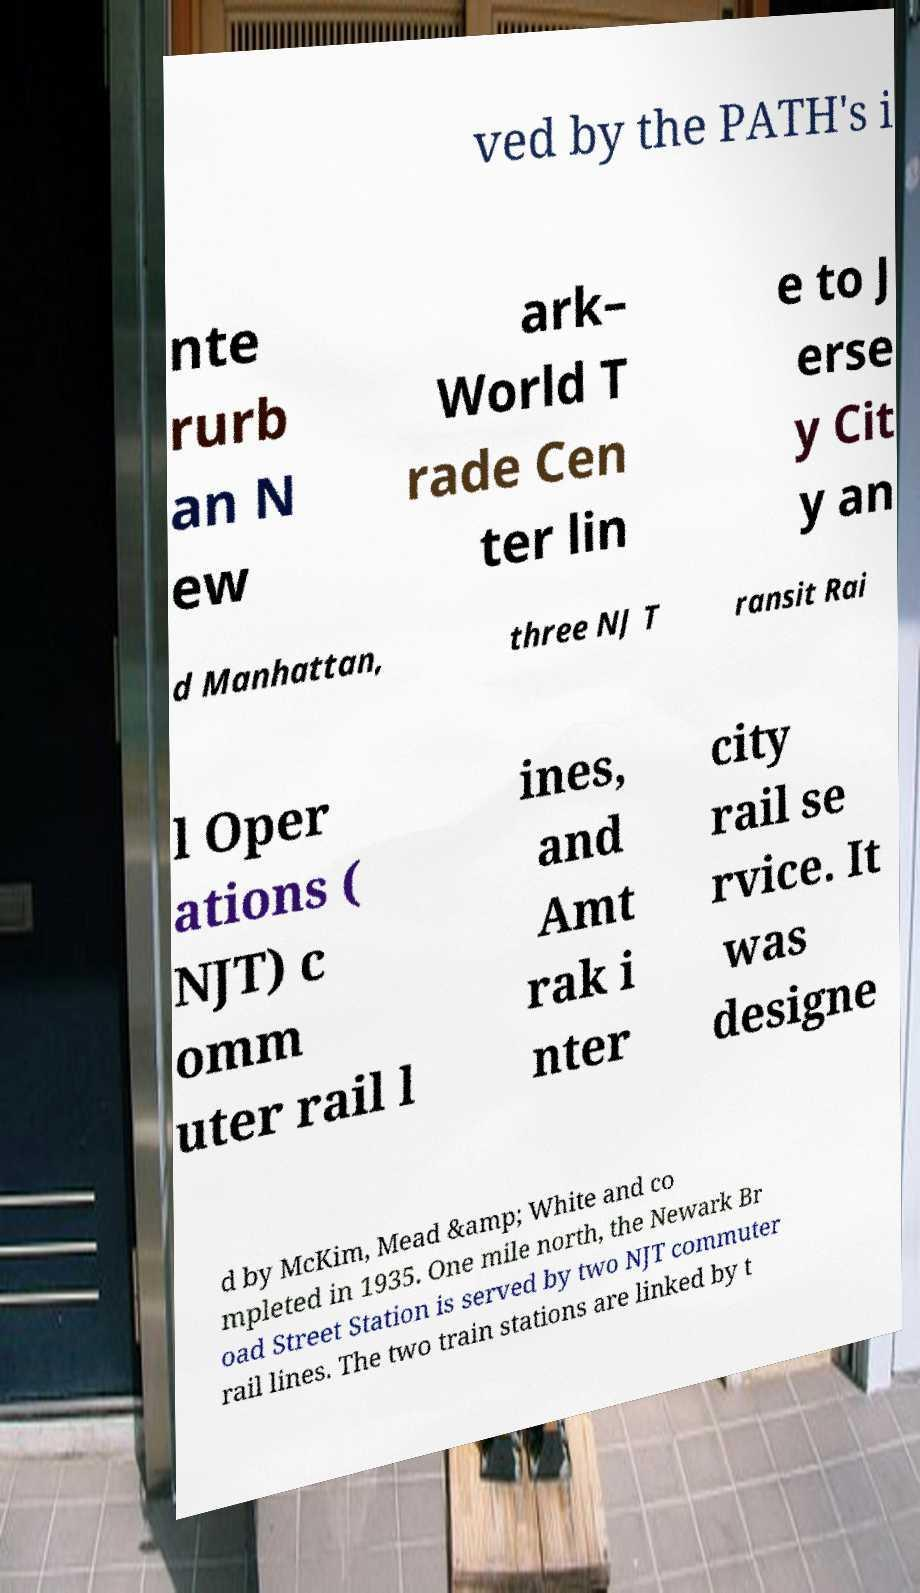Please read and relay the text visible in this image. What does it say? ved by the PATH's i nte rurb an N ew ark– World T rade Cen ter lin e to J erse y Cit y an d Manhattan, three NJ T ransit Rai l Oper ations ( NJT) c omm uter rail l ines, and Amt rak i nter city rail se rvice. It was designe d by McKim, Mead &amp; White and co mpleted in 1935. One mile north, the Newark Br oad Street Station is served by two NJT commuter rail lines. The two train stations are linked by t 